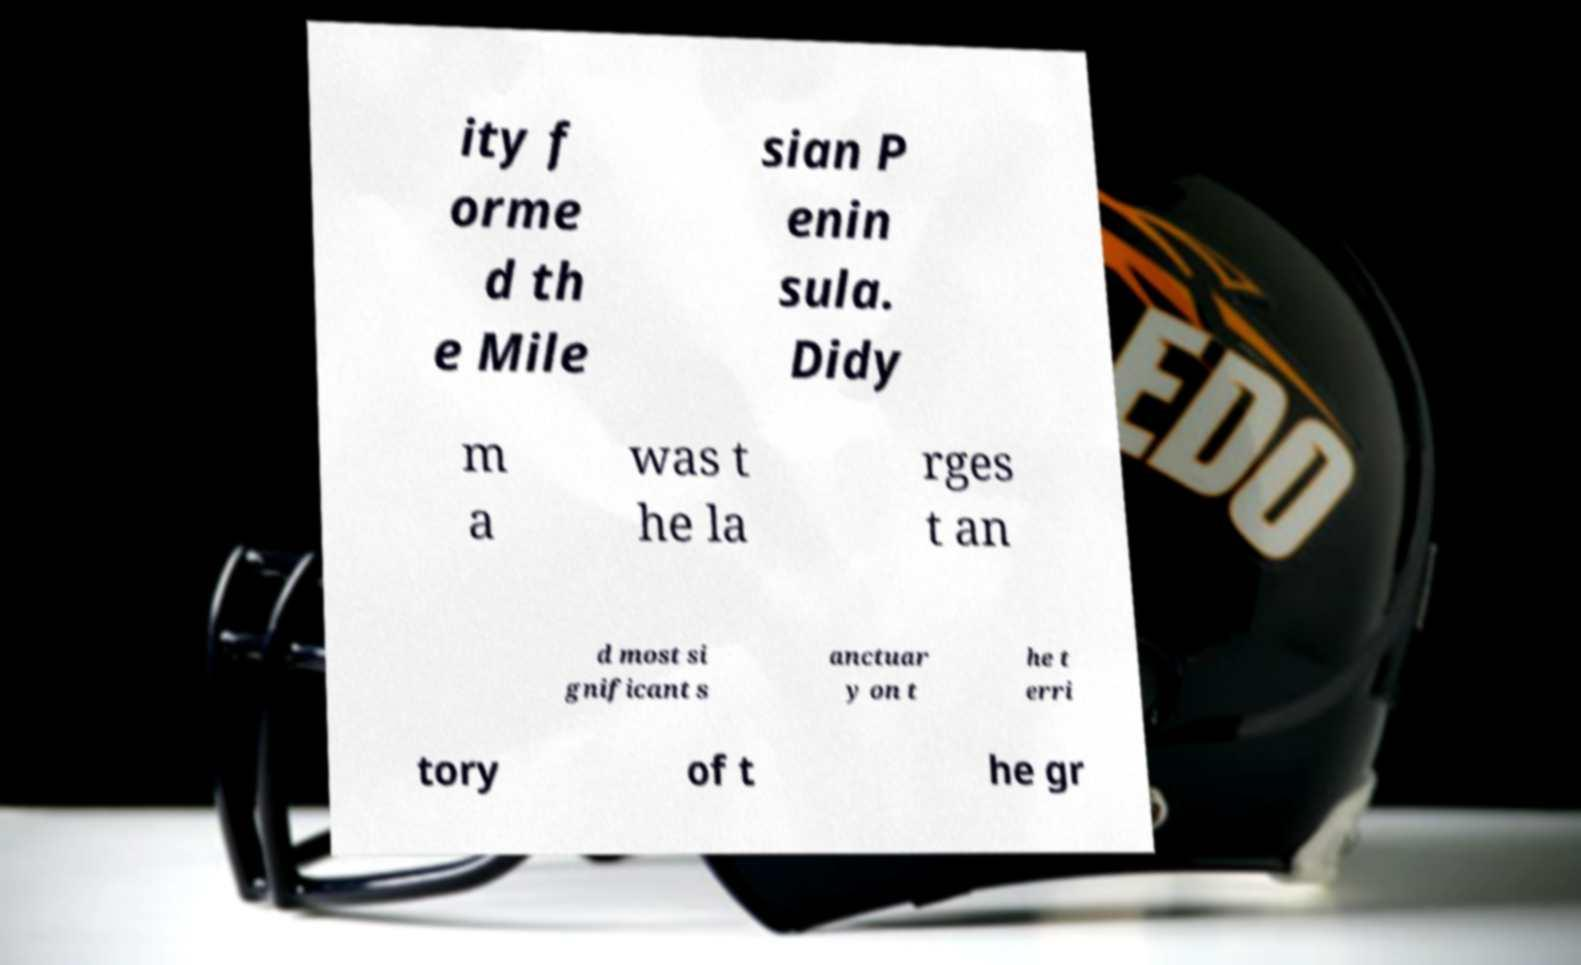Could you assist in decoding the text presented in this image and type it out clearly? ity f orme d th e Mile sian P enin sula. Didy m a was t he la rges t an d most si gnificant s anctuar y on t he t erri tory of t he gr 